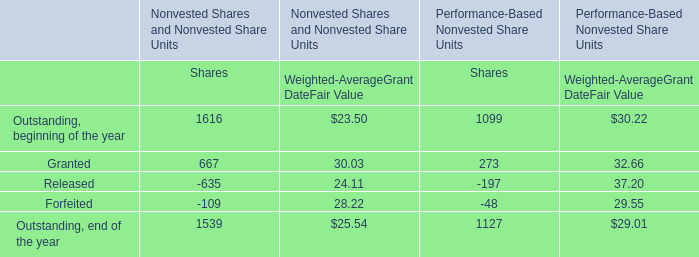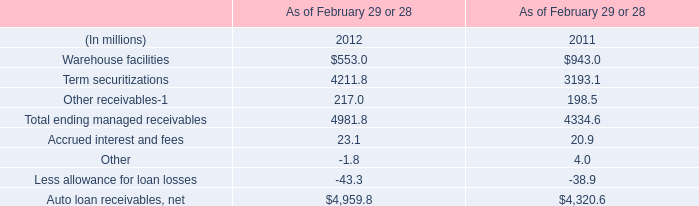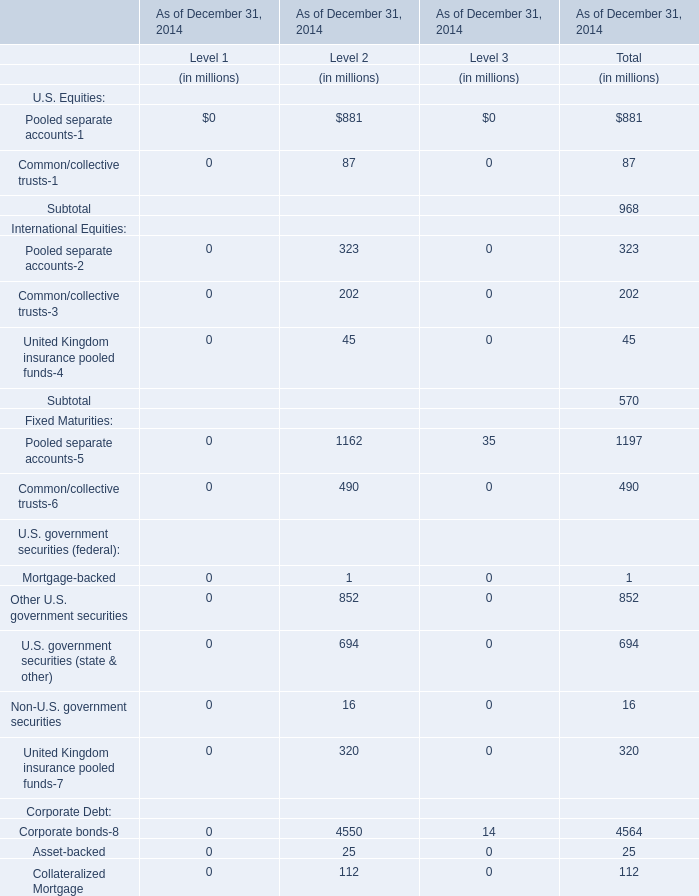Which element exceeds 18 % of total for Level 3 in 2014? 
Answer: Pooled separate accounts-12, Partnerships,Hedge funds. 